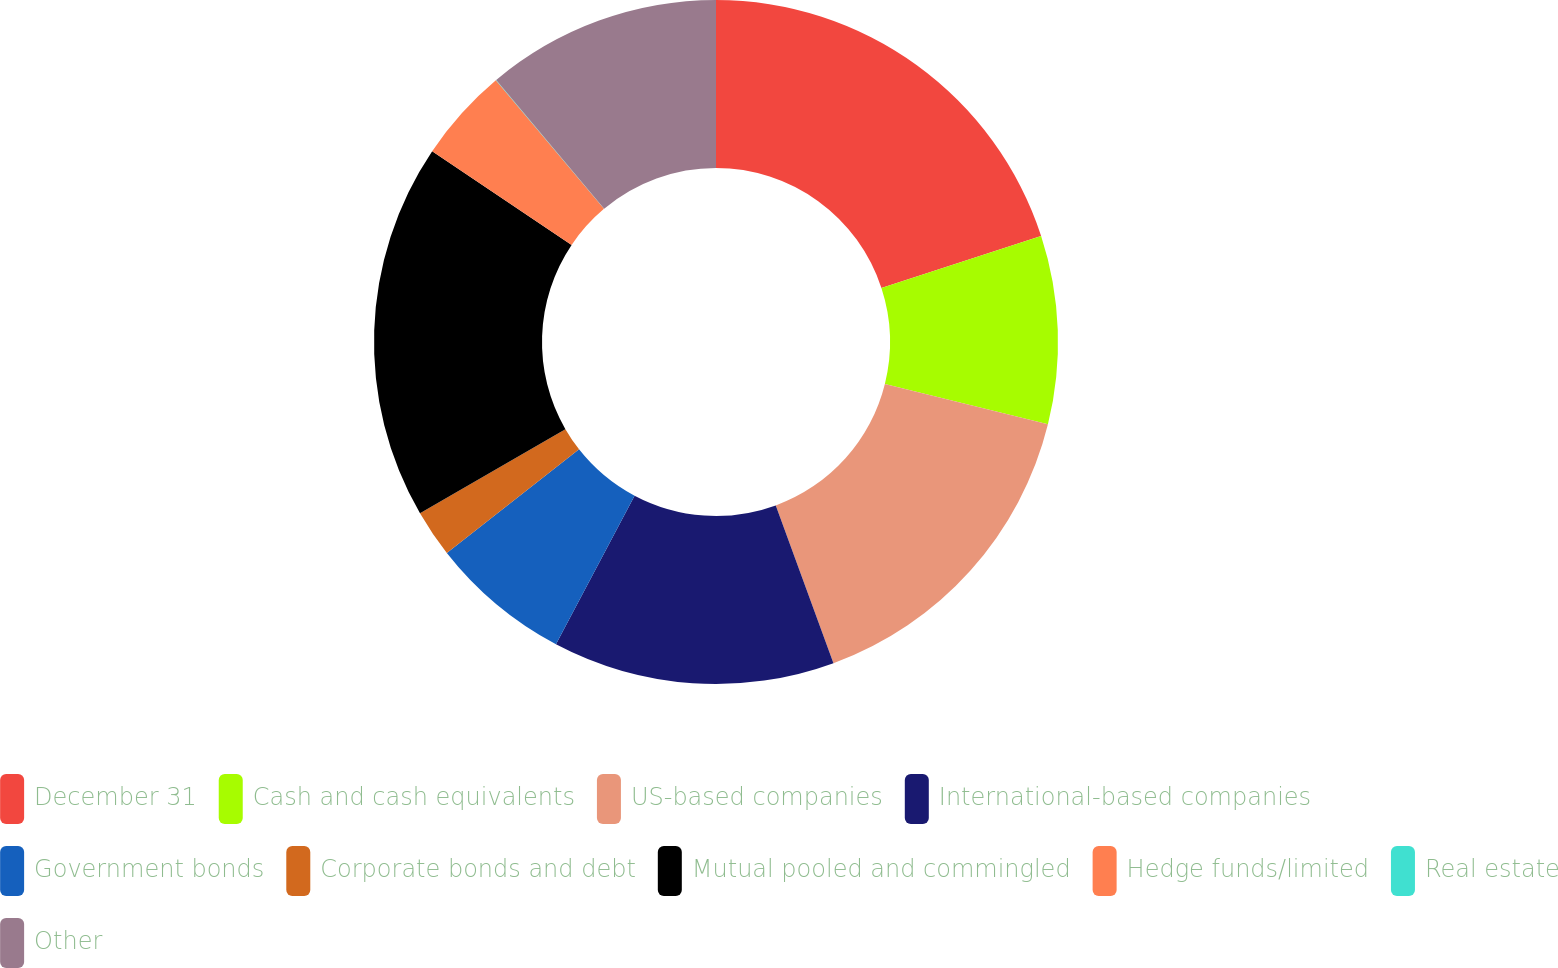<chart> <loc_0><loc_0><loc_500><loc_500><pie_chart><fcel>December 31<fcel>Cash and cash equivalents<fcel>US-based companies<fcel>International-based companies<fcel>Government bonds<fcel>Corporate bonds and debt<fcel>Mutual pooled and commingled<fcel>Hedge funds/limited<fcel>Real estate<fcel>Other<nl><fcel>19.98%<fcel>8.89%<fcel>15.55%<fcel>13.33%<fcel>6.67%<fcel>2.23%<fcel>17.77%<fcel>4.45%<fcel>0.02%<fcel>11.11%<nl></chart> 